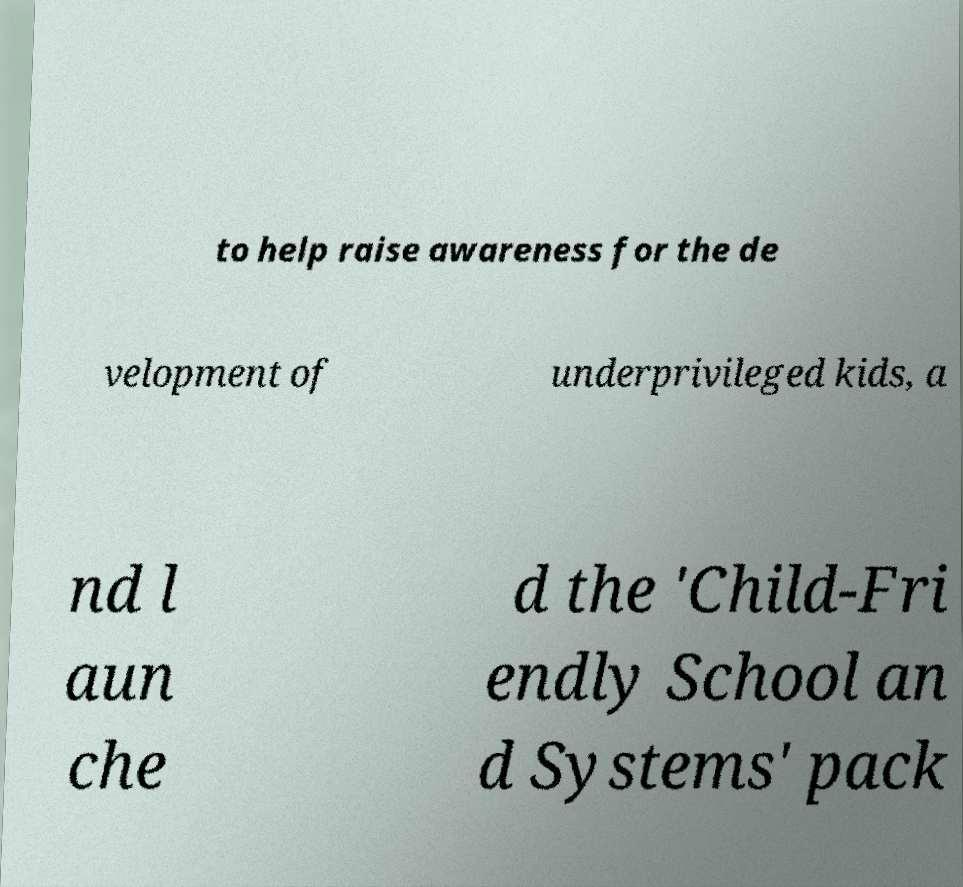Could you assist in decoding the text presented in this image and type it out clearly? to help raise awareness for the de velopment of underprivileged kids, a nd l aun che d the 'Child-Fri endly School an d Systems' pack 